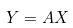Convert formula to latex. <formula><loc_0><loc_0><loc_500><loc_500>Y = A X</formula> 